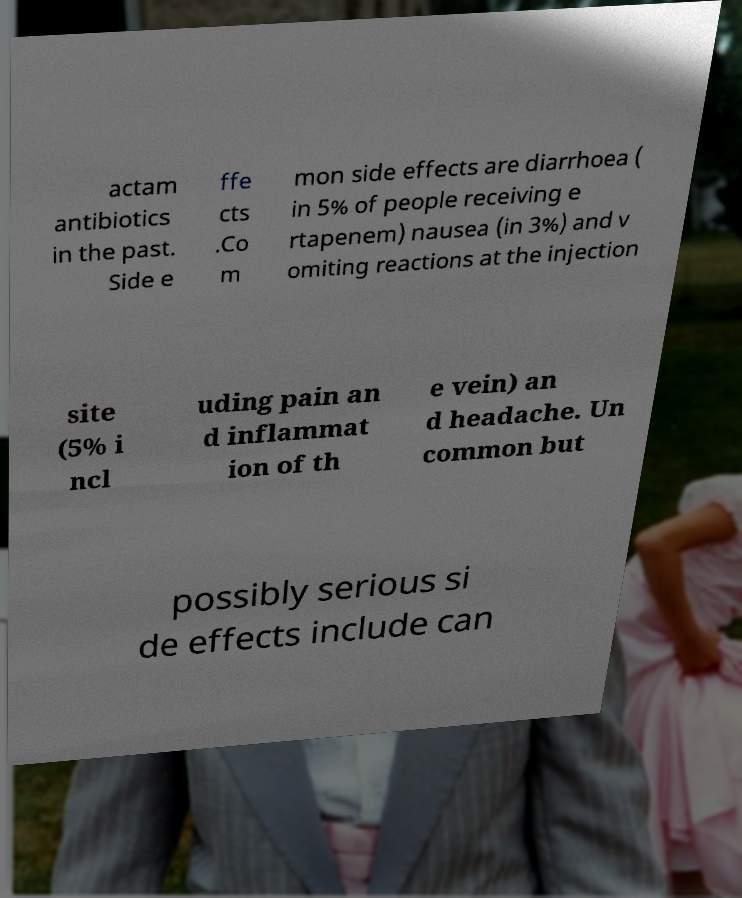Can you accurately transcribe the text from the provided image for me? actam antibiotics in the past. Side e ffe cts .Co m mon side effects are diarrhoea ( in 5% of people receiving e rtapenem) nausea (in 3%) and v omiting reactions at the injection site (5% i ncl uding pain an d inflammat ion of th e vein) an d headache. Un common but possibly serious si de effects include can 